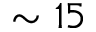<formula> <loc_0><loc_0><loc_500><loc_500>\sim 1 5</formula> 